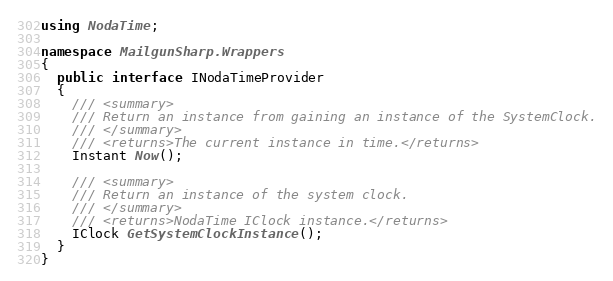<code> <loc_0><loc_0><loc_500><loc_500><_C#_>using NodaTime;

namespace MailgunSharp.Wrappers
{
  public interface INodaTimeProvider
  {
    /// <summary>
    /// Return an instance from gaining an instance of the SystemClock.
    /// </summary>
    /// <returns>The current instance in time.</returns>
    Instant Now();

    /// <summary>
    /// Return an instance of the system clock.
    /// </summary>
    /// <returns>NodaTime IClock instance.</returns>
    IClock GetSystemClockInstance();
  }
}</code> 